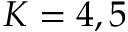<formula> <loc_0><loc_0><loc_500><loc_500>K = 4 , 5</formula> 